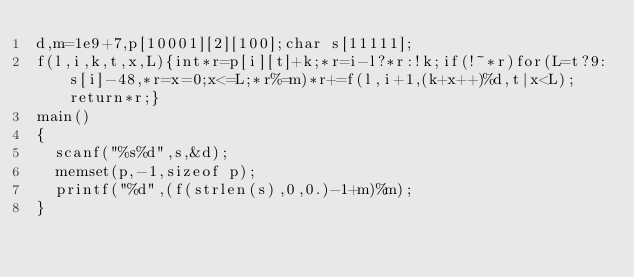<code> <loc_0><loc_0><loc_500><loc_500><_C_>d,m=1e9+7,p[10001][2][100];char s[11111];
f(l,i,k,t,x,L){int*r=p[i][t]+k;*r=i-l?*r:!k;if(!~*r)for(L=t?9:s[i]-48,*r=x=0;x<=L;*r%=m)*r+=f(l,i+1,(k+x++)%d,t|x<L);return*r;}
main()
{
	scanf("%s%d",s,&d);
	memset(p,-1,sizeof p);
	printf("%d",(f(strlen(s),0,0.)-1+m)%m);
}</code> 